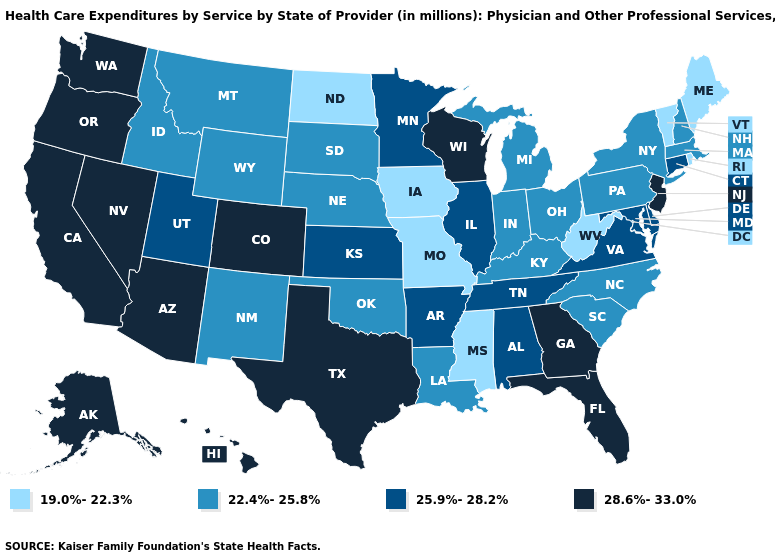What is the lowest value in the MidWest?
Short answer required. 19.0%-22.3%. Name the states that have a value in the range 25.9%-28.2%?
Write a very short answer. Alabama, Arkansas, Connecticut, Delaware, Illinois, Kansas, Maryland, Minnesota, Tennessee, Utah, Virginia. How many symbols are there in the legend?
Answer briefly. 4. What is the lowest value in states that border Missouri?
Be succinct. 19.0%-22.3%. What is the value of New York?
Give a very brief answer. 22.4%-25.8%. Does Colorado have the highest value in the USA?
Answer briefly. Yes. Does North Carolina have the lowest value in the USA?
Answer briefly. No. Among the states that border New Jersey , does New York have the lowest value?
Give a very brief answer. Yes. What is the value of Ohio?
Give a very brief answer. 22.4%-25.8%. Does New York have the lowest value in the Northeast?
Short answer required. No. What is the value of Wisconsin?
Short answer required. 28.6%-33.0%. What is the lowest value in the USA?
Give a very brief answer. 19.0%-22.3%. What is the value of North Carolina?
Give a very brief answer. 22.4%-25.8%. Does New Hampshire have a higher value than Vermont?
Be succinct. Yes. 